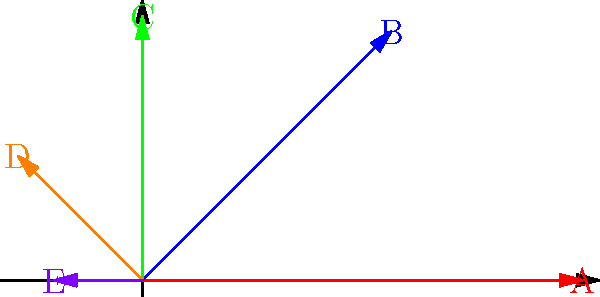In the vector diagram above, tasks A, B, C, D, and E are represented by vectors of different magnitudes and directions. The magnitude represents the time required for each task, while the direction indicates its importance (with vectors closer to the positive x-axis being more important). As a time-conscious professional, which task should be prioritized first, and why? To determine which task should be prioritized, we need to consider both the importance (direction) and the time required (magnitude) for each task. Let's analyze each vector:

1. Vector A: Longest vector (5 units) aligned with the positive x-axis (0°)
2. Vector B: Second longest vector (4 units) at 45° from the x-axis
3. Vector C: Third longest vector (3 units) perpendicular to the x-axis (90°)
4. Vector D: Fourth longest vector (2 units) at 135° from the x-axis
5. Vector E: Shortest vector (1 unit) aligned with the negative x-axis (180°)

The ideal task to prioritize would have high importance (close to 0°) and a manageable time requirement. 

Vector A has the highest importance (0°) but also requires the most time (5 units). While it's the most important, it might not be the most efficient choice given the time constraint.

Vector B offers a good balance between importance (45°) and time required (4 units). It's relatively important and doesn't take as long as A.

Vectors C, D, and E are less important due to their angles and have shorter lengths, making them lower priorities.

Considering the balance between importance and time efficiency, Vector B appears to be the best choice for prioritization. It's significantly important and can be completed in less time than the most important task (A).
Answer: Task B should be prioritized first, as it offers the best balance between importance and time efficiency. 